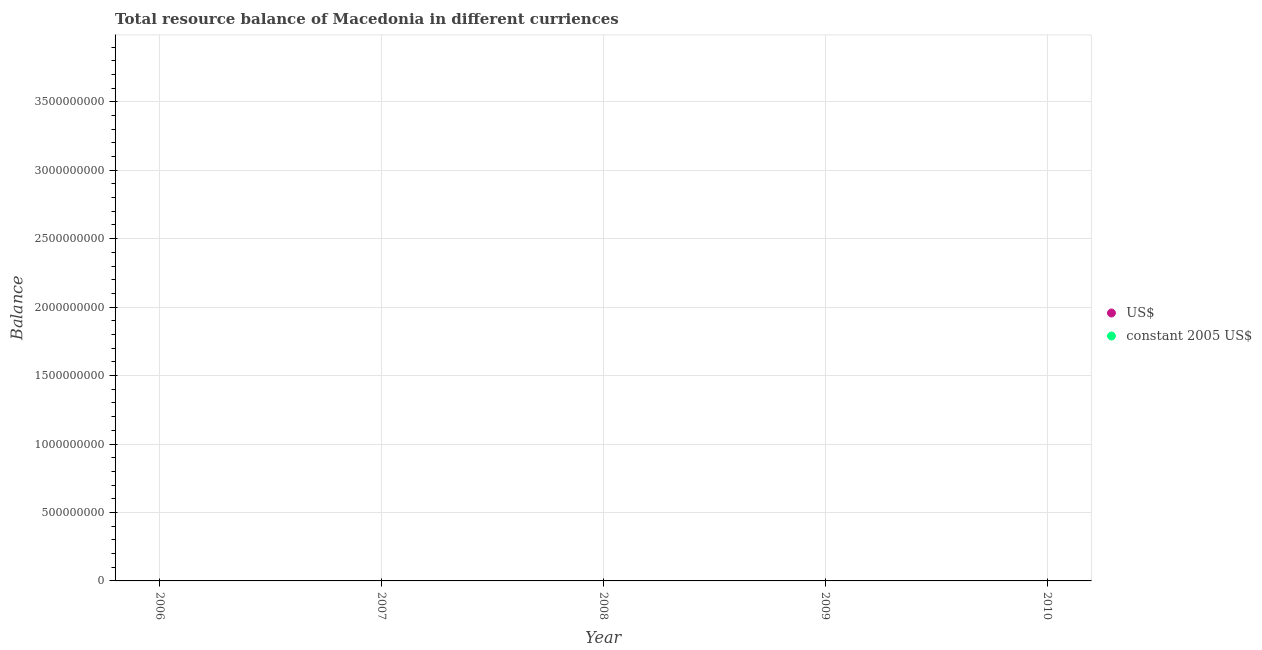What is the difference between the resource balance in constant us$ in 2007 and the resource balance in us$ in 2008?
Your response must be concise. 0. In how many years, is the resource balance in us$ greater than the average resource balance in us$ taken over all years?
Give a very brief answer. 0. Does the resource balance in constant us$ monotonically increase over the years?
Offer a terse response. No. Is the resource balance in constant us$ strictly greater than the resource balance in us$ over the years?
Keep it short and to the point. No. Is the resource balance in us$ strictly less than the resource balance in constant us$ over the years?
Your answer should be compact. No. How many years are there in the graph?
Ensure brevity in your answer.  5. What is the difference between two consecutive major ticks on the Y-axis?
Your response must be concise. 5.00e+08. Are the values on the major ticks of Y-axis written in scientific E-notation?
Keep it short and to the point. No. What is the title of the graph?
Provide a short and direct response. Total resource balance of Macedonia in different curriences. Does "UN agencies" appear as one of the legend labels in the graph?
Your response must be concise. No. What is the label or title of the X-axis?
Give a very brief answer. Year. What is the label or title of the Y-axis?
Your answer should be very brief. Balance. What is the Balance of US$ in 2006?
Offer a terse response. 0. What is the Balance in US$ in 2008?
Give a very brief answer. 0. What is the Balance of constant 2005 US$ in 2008?
Keep it short and to the point. 0. What is the Balance of US$ in 2009?
Provide a succinct answer. 0. What is the Balance in US$ in 2010?
Your answer should be very brief. 0. What is the Balance in constant 2005 US$ in 2010?
Give a very brief answer. 0. What is the total Balance in US$ in the graph?
Make the answer very short. 0. What is the average Balance of US$ per year?
Provide a succinct answer. 0. 